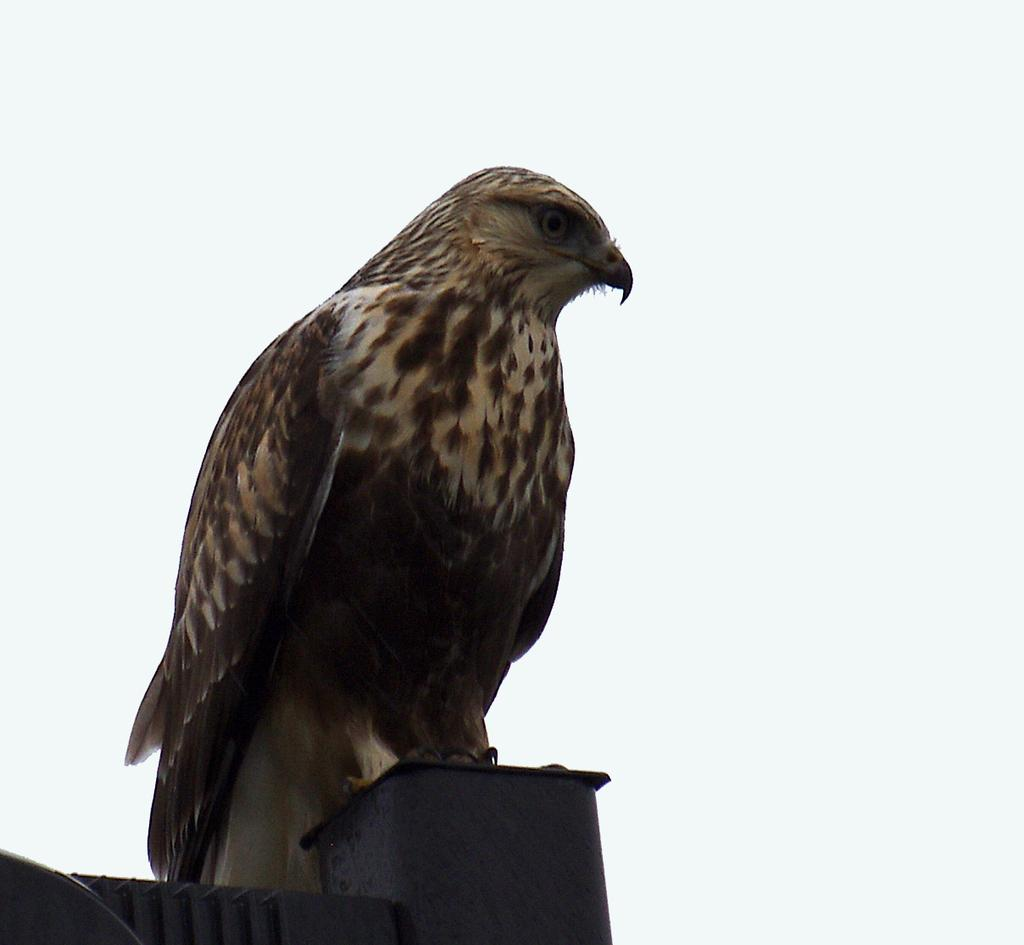What type of animal is in the image? There is a bird in the image. What colors can be seen on the bird? The bird has cream, black, and brown colors. What is the bird sitting on in the image? The bird is on a black object. What color is the background of the image? The background of the image is white. What type of straw is the bird using to build its nest in the image? There is no straw or nest visible in the image; it only features a bird on a black object with a white background. 